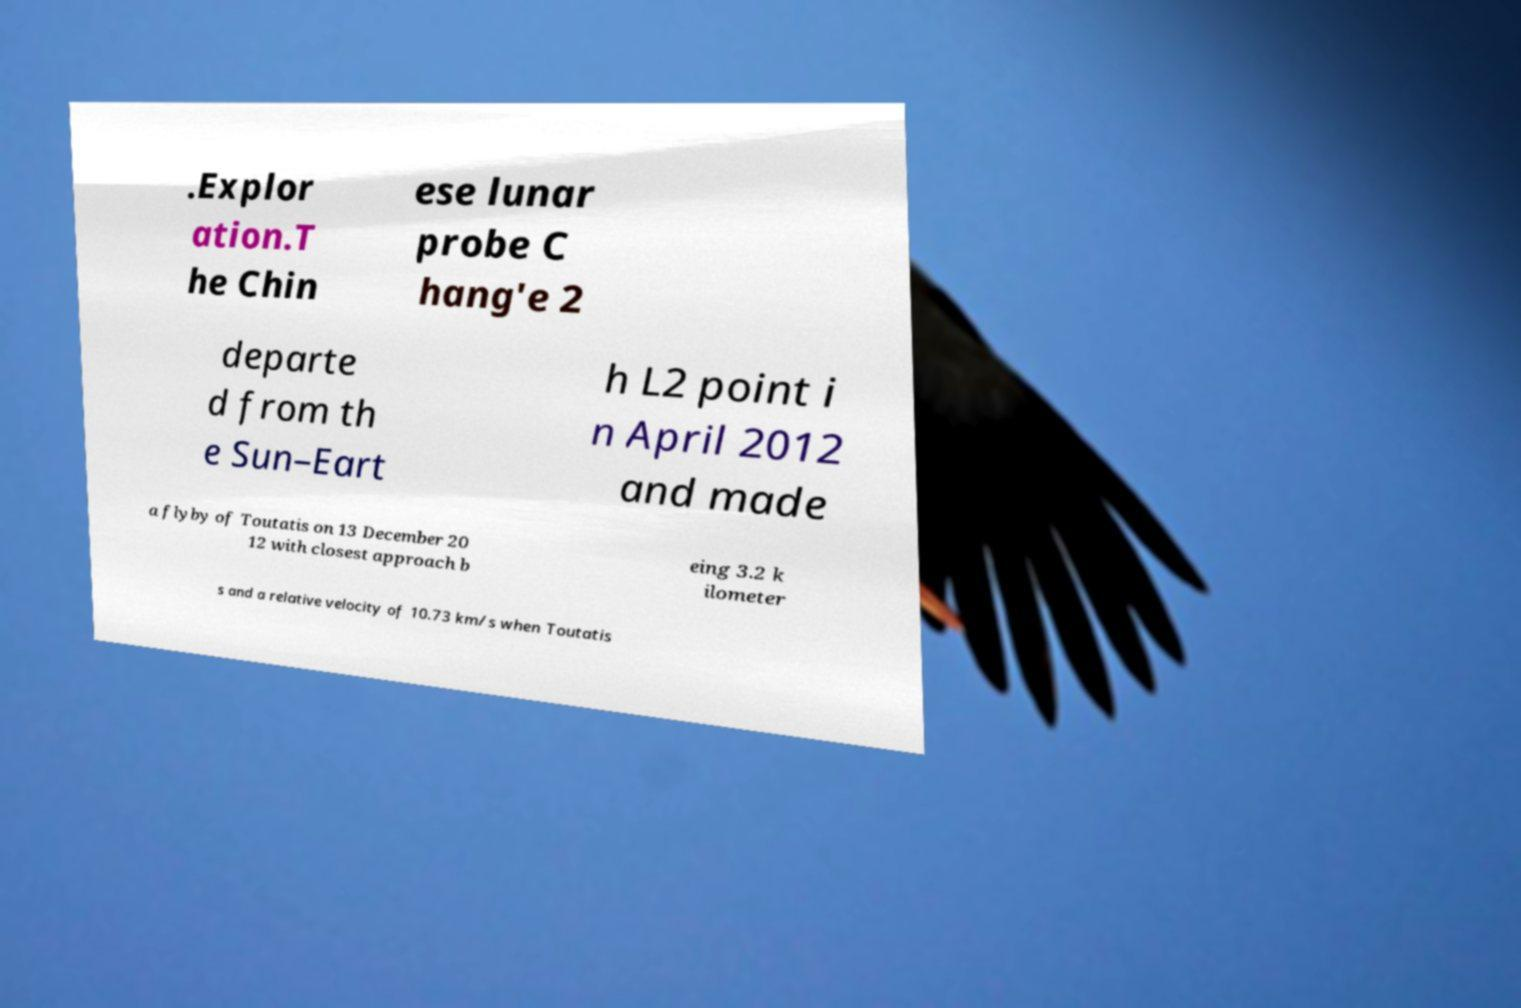For documentation purposes, I need the text within this image transcribed. Could you provide that? .Explor ation.T he Chin ese lunar probe C hang'e 2 departe d from th e Sun–Eart h L2 point i n April 2012 and made a flyby of Toutatis on 13 December 20 12 with closest approach b eing 3.2 k ilometer s and a relative velocity of 10.73 km/s when Toutatis 